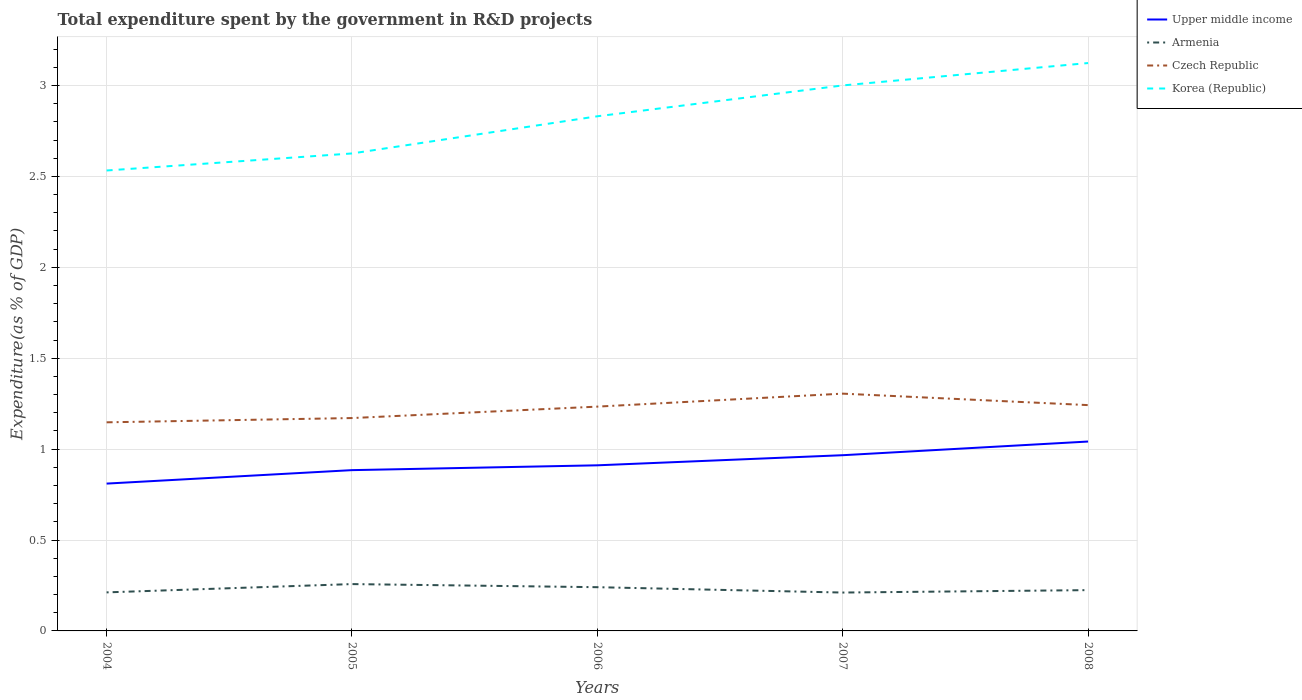How many different coloured lines are there?
Keep it short and to the point. 4. Across all years, what is the maximum total expenditure spent by the government in R&D projects in Armenia?
Your answer should be compact. 0.21. What is the total total expenditure spent by the government in R&D projects in Czech Republic in the graph?
Your response must be concise. -0.06. What is the difference between the highest and the second highest total expenditure spent by the government in R&D projects in Korea (Republic)?
Provide a short and direct response. 0.59. Is the total expenditure spent by the government in R&D projects in Armenia strictly greater than the total expenditure spent by the government in R&D projects in Czech Republic over the years?
Make the answer very short. Yes. How many lines are there?
Offer a very short reply. 4. Are the values on the major ticks of Y-axis written in scientific E-notation?
Give a very brief answer. No. Where does the legend appear in the graph?
Provide a short and direct response. Top right. How many legend labels are there?
Keep it short and to the point. 4. How are the legend labels stacked?
Give a very brief answer. Vertical. What is the title of the graph?
Provide a succinct answer. Total expenditure spent by the government in R&D projects. Does "Lesotho" appear as one of the legend labels in the graph?
Ensure brevity in your answer.  No. What is the label or title of the X-axis?
Make the answer very short. Years. What is the label or title of the Y-axis?
Make the answer very short. Expenditure(as % of GDP). What is the Expenditure(as % of GDP) of Upper middle income in 2004?
Your answer should be very brief. 0.81. What is the Expenditure(as % of GDP) in Armenia in 2004?
Your response must be concise. 0.21. What is the Expenditure(as % of GDP) of Czech Republic in 2004?
Ensure brevity in your answer.  1.15. What is the Expenditure(as % of GDP) in Korea (Republic) in 2004?
Your answer should be very brief. 2.53. What is the Expenditure(as % of GDP) of Upper middle income in 2005?
Make the answer very short. 0.88. What is the Expenditure(as % of GDP) of Armenia in 2005?
Give a very brief answer. 0.26. What is the Expenditure(as % of GDP) in Czech Republic in 2005?
Your answer should be compact. 1.17. What is the Expenditure(as % of GDP) of Korea (Republic) in 2005?
Make the answer very short. 2.63. What is the Expenditure(as % of GDP) of Upper middle income in 2006?
Provide a short and direct response. 0.91. What is the Expenditure(as % of GDP) in Armenia in 2006?
Your response must be concise. 0.24. What is the Expenditure(as % of GDP) in Czech Republic in 2006?
Offer a terse response. 1.23. What is the Expenditure(as % of GDP) of Korea (Republic) in 2006?
Offer a terse response. 2.83. What is the Expenditure(as % of GDP) of Upper middle income in 2007?
Your response must be concise. 0.97. What is the Expenditure(as % of GDP) in Armenia in 2007?
Keep it short and to the point. 0.21. What is the Expenditure(as % of GDP) in Czech Republic in 2007?
Your response must be concise. 1.31. What is the Expenditure(as % of GDP) of Korea (Republic) in 2007?
Provide a short and direct response. 3. What is the Expenditure(as % of GDP) in Upper middle income in 2008?
Offer a very short reply. 1.04. What is the Expenditure(as % of GDP) of Armenia in 2008?
Give a very brief answer. 0.22. What is the Expenditure(as % of GDP) of Czech Republic in 2008?
Provide a short and direct response. 1.24. What is the Expenditure(as % of GDP) in Korea (Republic) in 2008?
Offer a very short reply. 3.12. Across all years, what is the maximum Expenditure(as % of GDP) of Upper middle income?
Ensure brevity in your answer.  1.04. Across all years, what is the maximum Expenditure(as % of GDP) of Armenia?
Your answer should be compact. 0.26. Across all years, what is the maximum Expenditure(as % of GDP) in Czech Republic?
Provide a succinct answer. 1.31. Across all years, what is the maximum Expenditure(as % of GDP) in Korea (Republic)?
Your response must be concise. 3.12. Across all years, what is the minimum Expenditure(as % of GDP) in Upper middle income?
Offer a terse response. 0.81. Across all years, what is the minimum Expenditure(as % of GDP) in Armenia?
Your answer should be very brief. 0.21. Across all years, what is the minimum Expenditure(as % of GDP) in Czech Republic?
Your answer should be very brief. 1.15. Across all years, what is the minimum Expenditure(as % of GDP) in Korea (Republic)?
Give a very brief answer. 2.53. What is the total Expenditure(as % of GDP) of Upper middle income in the graph?
Ensure brevity in your answer.  4.61. What is the total Expenditure(as % of GDP) in Armenia in the graph?
Offer a very short reply. 1.15. What is the total Expenditure(as % of GDP) of Czech Republic in the graph?
Keep it short and to the point. 6.1. What is the total Expenditure(as % of GDP) in Korea (Republic) in the graph?
Keep it short and to the point. 14.11. What is the difference between the Expenditure(as % of GDP) in Upper middle income in 2004 and that in 2005?
Ensure brevity in your answer.  -0.07. What is the difference between the Expenditure(as % of GDP) of Armenia in 2004 and that in 2005?
Offer a terse response. -0.05. What is the difference between the Expenditure(as % of GDP) of Czech Republic in 2004 and that in 2005?
Your answer should be very brief. -0.02. What is the difference between the Expenditure(as % of GDP) of Korea (Republic) in 2004 and that in 2005?
Your response must be concise. -0.09. What is the difference between the Expenditure(as % of GDP) of Upper middle income in 2004 and that in 2006?
Offer a terse response. -0.1. What is the difference between the Expenditure(as % of GDP) of Armenia in 2004 and that in 2006?
Keep it short and to the point. -0.03. What is the difference between the Expenditure(as % of GDP) of Czech Republic in 2004 and that in 2006?
Make the answer very short. -0.09. What is the difference between the Expenditure(as % of GDP) of Korea (Republic) in 2004 and that in 2006?
Offer a very short reply. -0.3. What is the difference between the Expenditure(as % of GDP) of Upper middle income in 2004 and that in 2007?
Provide a short and direct response. -0.16. What is the difference between the Expenditure(as % of GDP) in Armenia in 2004 and that in 2007?
Ensure brevity in your answer.  0. What is the difference between the Expenditure(as % of GDP) of Czech Republic in 2004 and that in 2007?
Offer a terse response. -0.16. What is the difference between the Expenditure(as % of GDP) of Korea (Republic) in 2004 and that in 2007?
Ensure brevity in your answer.  -0.47. What is the difference between the Expenditure(as % of GDP) in Upper middle income in 2004 and that in 2008?
Make the answer very short. -0.23. What is the difference between the Expenditure(as % of GDP) in Armenia in 2004 and that in 2008?
Offer a very short reply. -0.01. What is the difference between the Expenditure(as % of GDP) in Czech Republic in 2004 and that in 2008?
Your answer should be very brief. -0.09. What is the difference between the Expenditure(as % of GDP) of Korea (Republic) in 2004 and that in 2008?
Keep it short and to the point. -0.59. What is the difference between the Expenditure(as % of GDP) in Upper middle income in 2005 and that in 2006?
Offer a very short reply. -0.03. What is the difference between the Expenditure(as % of GDP) in Armenia in 2005 and that in 2006?
Give a very brief answer. 0.02. What is the difference between the Expenditure(as % of GDP) of Czech Republic in 2005 and that in 2006?
Your response must be concise. -0.06. What is the difference between the Expenditure(as % of GDP) of Korea (Republic) in 2005 and that in 2006?
Make the answer very short. -0.2. What is the difference between the Expenditure(as % of GDP) of Upper middle income in 2005 and that in 2007?
Offer a very short reply. -0.08. What is the difference between the Expenditure(as % of GDP) of Armenia in 2005 and that in 2007?
Your answer should be very brief. 0.05. What is the difference between the Expenditure(as % of GDP) in Czech Republic in 2005 and that in 2007?
Offer a terse response. -0.13. What is the difference between the Expenditure(as % of GDP) of Korea (Republic) in 2005 and that in 2007?
Keep it short and to the point. -0.37. What is the difference between the Expenditure(as % of GDP) in Upper middle income in 2005 and that in 2008?
Make the answer very short. -0.16. What is the difference between the Expenditure(as % of GDP) of Armenia in 2005 and that in 2008?
Give a very brief answer. 0.03. What is the difference between the Expenditure(as % of GDP) in Czech Republic in 2005 and that in 2008?
Ensure brevity in your answer.  -0.07. What is the difference between the Expenditure(as % of GDP) in Korea (Republic) in 2005 and that in 2008?
Your response must be concise. -0.5. What is the difference between the Expenditure(as % of GDP) of Upper middle income in 2006 and that in 2007?
Offer a very short reply. -0.06. What is the difference between the Expenditure(as % of GDP) of Armenia in 2006 and that in 2007?
Give a very brief answer. 0.03. What is the difference between the Expenditure(as % of GDP) of Czech Republic in 2006 and that in 2007?
Your response must be concise. -0.07. What is the difference between the Expenditure(as % of GDP) of Korea (Republic) in 2006 and that in 2007?
Offer a terse response. -0.17. What is the difference between the Expenditure(as % of GDP) in Upper middle income in 2006 and that in 2008?
Ensure brevity in your answer.  -0.13. What is the difference between the Expenditure(as % of GDP) in Armenia in 2006 and that in 2008?
Ensure brevity in your answer.  0.02. What is the difference between the Expenditure(as % of GDP) in Czech Republic in 2006 and that in 2008?
Keep it short and to the point. -0.01. What is the difference between the Expenditure(as % of GDP) of Korea (Republic) in 2006 and that in 2008?
Ensure brevity in your answer.  -0.29. What is the difference between the Expenditure(as % of GDP) in Upper middle income in 2007 and that in 2008?
Offer a terse response. -0.08. What is the difference between the Expenditure(as % of GDP) in Armenia in 2007 and that in 2008?
Ensure brevity in your answer.  -0.01. What is the difference between the Expenditure(as % of GDP) of Czech Republic in 2007 and that in 2008?
Your response must be concise. 0.06. What is the difference between the Expenditure(as % of GDP) of Korea (Republic) in 2007 and that in 2008?
Make the answer very short. -0.12. What is the difference between the Expenditure(as % of GDP) in Upper middle income in 2004 and the Expenditure(as % of GDP) in Armenia in 2005?
Provide a short and direct response. 0.55. What is the difference between the Expenditure(as % of GDP) of Upper middle income in 2004 and the Expenditure(as % of GDP) of Czech Republic in 2005?
Provide a succinct answer. -0.36. What is the difference between the Expenditure(as % of GDP) in Upper middle income in 2004 and the Expenditure(as % of GDP) in Korea (Republic) in 2005?
Keep it short and to the point. -1.82. What is the difference between the Expenditure(as % of GDP) in Armenia in 2004 and the Expenditure(as % of GDP) in Czech Republic in 2005?
Ensure brevity in your answer.  -0.96. What is the difference between the Expenditure(as % of GDP) in Armenia in 2004 and the Expenditure(as % of GDP) in Korea (Republic) in 2005?
Your response must be concise. -2.41. What is the difference between the Expenditure(as % of GDP) in Czech Republic in 2004 and the Expenditure(as % of GDP) in Korea (Republic) in 2005?
Provide a short and direct response. -1.48. What is the difference between the Expenditure(as % of GDP) in Upper middle income in 2004 and the Expenditure(as % of GDP) in Armenia in 2006?
Make the answer very short. 0.57. What is the difference between the Expenditure(as % of GDP) in Upper middle income in 2004 and the Expenditure(as % of GDP) in Czech Republic in 2006?
Provide a short and direct response. -0.42. What is the difference between the Expenditure(as % of GDP) of Upper middle income in 2004 and the Expenditure(as % of GDP) of Korea (Republic) in 2006?
Keep it short and to the point. -2.02. What is the difference between the Expenditure(as % of GDP) in Armenia in 2004 and the Expenditure(as % of GDP) in Czech Republic in 2006?
Give a very brief answer. -1.02. What is the difference between the Expenditure(as % of GDP) of Armenia in 2004 and the Expenditure(as % of GDP) of Korea (Republic) in 2006?
Your response must be concise. -2.62. What is the difference between the Expenditure(as % of GDP) of Czech Republic in 2004 and the Expenditure(as % of GDP) of Korea (Republic) in 2006?
Ensure brevity in your answer.  -1.68. What is the difference between the Expenditure(as % of GDP) in Upper middle income in 2004 and the Expenditure(as % of GDP) in Armenia in 2007?
Offer a terse response. 0.6. What is the difference between the Expenditure(as % of GDP) in Upper middle income in 2004 and the Expenditure(as % of GDP) in Czech Republic in 2007?
Offer a terse response. -0.49. What is the difference between the Expenditure(as % of GDP) in Upper middle income in 2004 and the Expenditure(as % of GDP) in Korea (Republic) in 2007?
Offer a terse response. -2.19. What is the difference between the Expenditure(as % of GDP) of Armenia in 2004 and the Expenditure(as % of GDP) of Czech Republic in 2007?
Offer a terse response. -1.09. What is the difference between the Expenditure(as % of GDP) in Armenia in 2004 and the Expenditure(as % of GDP) in Korea (Republic) in 2007?
Provide a short and direct response. -2.79. What is the difference between the Expenditure(as % of GDP) of Czech Republic in 2004 and the Expenditure(as % of GDP) of Korea (Republic) in 2007?
Ensure brevity in your answer.  -1.85. What is the difference between the Expenditure(as % of GDP) in Upper middle income in 2004 and the Expenditure(as % of GDP) in Armenia in 2008?
Your answer should be very brief. 0.59. What is the difference between the Expenditure(as % of GDP) of Upper middle income in 2004 and the Expenditure(as % of GDP) of Czech Republic in 2008?
Ensure brevity in your answer.  -0.43. What is the difference between the Expenditure(as % of GDP) in Upper middle income in 2004 and the Expenditure(as % of GDP) in Korea (Republic) in 2008?
Ensure brevity in your answer.  -2.31. What is the difference between the Expenditure(as % of GDP) in Armenia in 2004 and the Expenditure(as % of GDP) in Czech Republic in 2008?
Your answer should be very brief. -1.03. What is the difference between the Expenditure(as % of GDP) in Armenia in 2004 and the Expenditure(as % of GDP) in Korea (Republic) in 2008?
Provide a short and direct response. -2.91. What is the difference between the Expenditure(as % of GDP) of Czech Republic in 2004 and the Expenditure(as % of GDP) of Korea (Republic) in 2008?
Your response must be concise. -1.98. What is the difference between the Expenditure(as % of GDP) in Upper middle income in 2005 and the Expenditure(as % of GDP) in Armenia in 2006?
Give a very brief answer. 0.64. What is the difference between the Expenditure(as % of GDP) of Upper middle income in 2005 and the Expenditure(as % of GDP) of Czech Republic in 2006?
Your answer should be compact. -0.35. What is the difference between the Expenditure(as % of GDP) of Upper middle income in 2005 and the Expenditure(as % of GDP) of Korea (Republic) in 2006?
Offer a very short reply. -1.95. What is the difference between the Expenditure(as % of GDP) of Armenia in 2005 and the Expenditure(as % of GDP) of Czech Republic in 2006?
Offer a very short reply. -0.98. What is the difference between the Expenditure(as % of GDP) of Armenia in 2005 and the Expenditure(as % of GDP) of Korea (Republic) in 2006?
Offer a very short reply. -2.57. What is the difference between the Expenditure(as % of GDP) in Czech Republic in 2005 and the Expenditure(as % of GDP) in Korea (Republic) in 2006?
Offer a terse response. -1.66. What is the difference between the Expenditure(as % of GDP) in Upper middle income in 2005 and the Expenditure(as % of GDP) in Armenia in 2007?
Your answer should be compact. 0.67. What is the difference between the Expenditure(as % of GDP) of Upper middle income in 2005 and the Expenditure(as % of GDP) of Czech Republic in 2007?
Your answer should be compact. -0.42. What is the difference between the Expenditure(as % of GDP) in Upper middle income in 2005 and the Expenditure(as % of GDP) in Korea (Republic) in 2007?
Offer a terse response. -2.12. What is the difference between the Expenditure(as % of GDP) of Armenia in 2005 and the Expenditure(as % of GDP) of Czech Republic in 2007?
Offer a terse response. -1.05. What is the difference between the Expenditure(as % of GDP) of Armenia in 2005 and the Expenditure(as % of GDP) of Korea (Republic) in 2007?
Keep it short and to the point. -2.74. What is the difference between the Expenditure(as % of GDP) of Czech Republic in 2005 and the Expenditure(as % of GDP) of Korea (Republic) in 2007?
Your response must be concise. -1.83. What is the difference between the Expenditure(as % of GDP) of Upper middle income in 2005 and the Expenditure(as % of GDP) of Armenia in 2008?
Provide a short and direct response. 0.66. What is the difference between the Expenditure(as % of GDP) in Upper middle income in 2005 and the Expenditure(as % of GDP) in Czech Republic in 2008?
Provide a short and direct response. -0.36. What is the difference between the Expenditure(as % of GDP) in Upper middle income in 2005 and the Expenditure(as % of GDP) in Korea (Republic) in 2008?
Ensure brevity in your answer.  -2.24. What is the difference between the Expenditure(as % of GDP) of Armenia in 2005 and the Expenditure(as % of GDP) of Czech Republic in 2008?
Provide a succinct answer. -0.98. What is the difference between the Expenditure(as % of GDP) in Armenia in 2005 and the Expenditure(as % of GDP) in Korea (Republic) in 2008?
Make the answer very short. -2.87. What is the difference between the Expenditure(as % of GDP) of Czech Republic in 2005 and the Expenditure(as % of GDP) of Korea (Republic) in 2008?
Your answer should be compact. -1.95. What is the difference between the Expenditure(as % of GDP) in Upper middle income in 2006 and the Expenditure(as % of GDP) in Armenia in 2007?
Your response must be concise. 0.7. What is the difference between the Expenditure(as % of GDP) in Upper middle income in 2006 and the Expenditure(as % of GDP) in Czech Republic in 2007?
Offer a very short reply. -0.39. What is the difference between the Expenditure(as % of GDP) in Upper middle income in 2006 and the Expenditure(as % of GDP) in Korea (Republic) in 2007?
Provide a short and direct response. -2.09. What is the difference between the Expenditure(as % of GDP) of Armenia in 2006 and the Expenditure(as % of GDP) of Czech Republic in 2007?
Make the answer very short. -1.06. What is the difference between the Expenditure(as % of GDP) in Armenia in 2006 and the Expenditure(as % of GDP) in Korea (Republic) in 2007?
Keep it short and to the point. -2.76. What is the difference between the Expenditure(as % of GDP) of Czech Republic in 2006 and the Expenditure(as % of GDP) of Korea (Republic) in 2007?
Provide a succinct answer. -1.77. What is the difference between the Expenditure(as % of GDP) of Upper middle income in 2006 and the Expenditure(as % of GDP) of Armenia in 2008?
Provide a short and direct response. 0.69. What is the difference between the Expenditure(as % of GDP) in Upper middle income in 2006 and the Expenditure(as % of GDP) in Czech Republic in 2008?
Offer a terse response. -0.33. What is the difference between the Expenditure(as % of GDP) in Upper middle income in 2006 and the Expenditure(as % of GDP) in Korea (Republic) in 2008?
Give a very brief answer. -2.21. What is the difference between the Expenditure(as % of GDP) of Armenia in 2006 and the Expenditure(as % of GDP) of Czech Republic in 2008?
Your response must be concise. -1. What is the difference between the Expenditure(as % of GDP) of Armenia in 2006 and the Expenditure(as % of GDP) of Korea (Republic) in 2008?
Make the answer very short. -2.88. What is the difference between the Expenditure(as % of GDP) of Czech Republic in 2006 and the Expenditure(as % of GDP) of Korea (Republic) in 2008?
Keep it short and to the point. -1.89. What is the difference between the Expenditure(as % of GDP) in Upper middle income in 2007 and the Expenditure(as % of GDP) in Armenia in 2008?
Keep it short and to the point. 0.74. What is the difference between the Expenditure(as % of GDP) in Upper middle income in 2007 and the Expenditure(as % of GDP) in Czech Republic in 2008?
Ensure brevity in your answer.  -0.28. What is the difference between the Expenditure(as % of GDP) in Upper middle income in 2007 and the Expenditure(as % of GDP) in Korea (Republic) in 2008?
Keep it short and to the point. -2.16. What is the difference between the Expenditure(as % of GDP) of Armenia in 2007 and the Expenditure(as % of GDP) of Czech Republic in 2008?
Your answer should be very brief. -1.03. What is the difference between the Expenditure(as % of GDP) in Armenia in 2007 and the Expenditure(as % of GDP) in Korea (Republic) in 2008?
Give a very brief answer. -2.91. What is the difference between the Expenditure(as % of GDP) in Czech Republic in 2007 and the Expenditure(as % of GDP) in Korea (Republic) in 2008?
Make the answer very short. -1.82. What is the average Expenditure(as % of GDP) in Upper middle income per year?
Provide a short and direct response. 0.92. What is the average Expenditure(as % of GDP) in Armenia per year?
Offer a very short reply. 0.23. What is the average Expenditure(as % of GDP) in Czech Republic per year?
Make the answer very short. 1.22. What is the average Expenditure(as % of GDP) in Korea (Republic) per year?
Your answer should be very brief. 2.82. In the year 2004, what is the difference between the Expenditure(as % of GDP) of Upper middle income and Expenditure(as % of GDP) of Armenia?
Keep it short and to the point. 0.6. In the year 2004, what is the difference between the Expenditure(as % of GDP) in Upper middle income and Expenditure(as % of GDP) in Czech Republic?
Keep it short and to the point. -0.34. In the year 2004, what is the difference between the Expenditure(as % of GDP) of Upper middle income and Expenditure(as % of GDP) of Korea (Republic)?
Your answer should be compact. -1.72. In the year 2004, what is the difference between the Expenditure(as % of GDP) of Armenia and Expenditure(as % of GDP) of Czech Republic?
Your response must be concise. -0.94. In the year 2004, what is the difference between the Expenditure(as % of GDP) in Armenia and Expenditure(as % of GDP) in Korea (Republic)?
Your answer should be compact. -2.32. In the year 2004, what is the difference between the Expenditure(as % of GDP) of Czech Republic and Expenditure(as % of GDP) of Korea (Republic)?
Keep it short and to the point. -1.39. In the year 2005, what is the difference between the Expenditure(as % of GDP) in Upper middle income and Expenditure(as % of GDP) in Armenia?
Your response must be concise. 0.63. In the year 2005, what is the difference between the Expenditure(as % of GDP) of Upper middle income and Expenditure(as % of GDP) of Czech Republic?
Offer a very short reply. -0.29. In the year 2005, what is the difference between the Expenditure(as % of GDP) in Upper middle income and Expenditure(as % of GDP) in Korea (Republic)?
Offer a very short reply. -1.74. In the year 2005, what is the difference between the Expenditure(as % of GDP) in Armenia and Expenditure(as % of GDP) in Czech Republic?
Ensure brevity in your answer.  -0.91. In the year 2005, what is the difference between the Expenditure(as % of GDP) in Armenia and Expenditure(as % of GDP) in Korea (Republic)?
Provide a short and direct response. -2.37. In the year 2005, what is the difference between the Expenditure(as % of GDP) in Czech Republic and Expenditure(as % of GDP) in Korea (Republic)?
Your answer should be very brief. -1.46. In the year 2006, what is the difference between the Expenditure(as % of GDP) of Upper middle income and Expenditure(as % of GDP) of Armenia?
Offer a terse response. 0.67. In the year 2006, what is the difference between the Expenditure(as % of GDP) in Upper middle income and Expenditure(as % of GDP) in Czech Republic?
Provide a succinct answer. -0.32. In the year 2006, what is the difference between the Expenditure(as % of GDP) in Upper middle income and Expenditure(as % of GDP) in Korea (Republic)?
Provide a short and direct response. -1.92. In the year 2006, what is the difference between the Expenditure(as % of GDP) of Armenia and Expenditure(as % of GDP) of Czech Republic?
Keep it short and to the point. -0.99. In the year 2006, what is the difference between the Expenditure(as % of GDP) in Armenia and Expenditure(as % of GDP) in Korea (Republic)?
Provide a succinct answer. -2.59. In the year 2006, what is the difference between the Expenditure(as % of GDP) in Czech Republic and Expenditure(as % of GDP) in Korea (Republic)?
Give a very brief answer. -1.6. In the year 2007, what is the difference between the Expenditure(as % of GDP) in Upper middle income and Expenditure(as % of GDP) in Armenia?
Keep it short and to the point. 0.76. In the year 2007, what is the difference between the Expenditure(as % of GDP) in Upper middle income and Expenditure(as % of GDP) in Czech Republic?
Ensure brevity in your answer.  -0.34. In the year 2007, what is the difference between the Expenditure(as % of GDP) in Upper middle income and Expenditure(as % of GDP) in Korea (Republic)?
Give a very brief answer. -2.03. In the year 2007, what is the difference between the Expenditure(as % of GDP) in Armenia and Expenditure(as % of GDP) in Czech Republic?
Keep it short and to the point. -1.09. In the year 2007, what is the difference between the Expenditure(as % of GDP) in Armenia and Expenditure(as % of GDP) in Korea (Republic)?
Your answer should be compact. -2.79. In the year 2007, what is the difference between the Expenditure(as % of GDP) in Czech Republic and Expenditure(as % of GDP) in Korea (Republic)?
Provide a short and direct response. -1.7. In the year 2008, what is the difference between the Expenditure(as % of GDP) in Upper middle income and Expenditure(as % of GDP) in Armenia?
Keep it short and to the point. 0.82. In the year 2008, what is the difference between the Expenditure(as % of GDP) of Upper middle income and Expenditure(as % of GDP) of Czech Republic?
Ensure brevity in your answer.  -0.2. In the year 2008, what is the difference between the Expenditure(as % of GDP) of Upper middle income and Expenditure(as % of GDP) of Korea (Republic)?
Give a very brief answer. -2.08. In the year 2008, what is the difference between the Expenditure(as % of GDP) in Armenia and Expenditure(as % of GDP) in Czech Republic?
Your response must be concise. -1.02. In the year 2008, what is the difference between the Expenditure(as % of GDP) of Armenia and Expenditure(as % of GDP) of Korea (Republic)?
Your answer should be compact. -2.9. In the year 2008, what is the difference between the Expenditure(as % of GDP) in Czech Republic and Expenditure(as % of GDP) in Korea (Republic)?
Your answer should be compact. -1.88. What is the ratio of the Expenditure(as % of GDP) of Upper middle income in 2004 to that in 2005?
Provide a short and direct response. 0.92. What is the ratio of the Expenditure(as % of GDP) of Armenia in 2004 to that in 2005?
Make the answer very short. 0.82. What is the ratio of the Expenditure(as % of GDP) of Upper middle income in 2004 to that in 2006?
Provide a short and direct response. 0.89. What is the ratio of the Expenditure(as % of GDP) of Armenia in 2004 to that in 2006?
Make the answer very short. 0.88. What is the ratio of the Expenditure(as % of GDP) in Czech Republic in 2004 to that in 2006?
Your response must be concise. 0.93. What is the ratio of the Expenditure(as % of GDP) in Korea (Republic) in 2004 to that in 2006?
Give a very brief answer. 0.89. What is the ratio of the Expenditure(as % of GDP) in Upper middle income in 2004 to that in 2007?
Your answer should be compact. 0.84. What is the ratio of the Expenditure(as % of GDP) in Czech Republic in 2004 to that in 2007?
Keep it short and to the point. 0.88. What is the ratio of the Expenditure(as % of GDP) of Korea (Republic) in 2004 to that in 2007?
Offer a terse response. 0.84. What is the ratio of the Expenditure(as % of GDP) in Upper middle income in 2004 to that in 2008?
Keep it short and to the point. 0.78. What is the ratio of the Expenditure(as % of GDP) of Armenia in 2004 to that in 2008?
Provide a short and direct response. 0.94. What is the ratio of the Expenditure(as % of GDP) of Czech Republic in 2004 to that in 2008?
Provide a short and direct response. 0.92. What is the ratio of the Expenditure(as % of GDP) of Korea (Republic) in 2004 to that in 2008?
Offer a very short reply. 0.81. What is the ratio of the Expenditure(as % of GDP) in Upper middle income in 2005 to that in 2006?
Keep it short and to the point. 0.97. What is the ratio of the Expenditure(as % of GDP) of Armenia in 2005 to that in 2006?
Your answer should be compact. 1.07. What is the ratio of the Expenditure(as % of GDP) of Czech Republic in 2005 to that in 2006?
Offer a terse response. 0.95. What is the ratio of the Expenditure(as % of GDP) in Korea (Republic) in 2005 to that in 2006?
Offer a very short reply. 0.93. What is the ratio of the Expenditure(as % of GDP) in Upper middle income in 2005 to that in 2007?
Give a very brief answer. 0.92. What is the ratio of the Expenditure(as % of GDP) in Armenia in 2005 to that in 2007?
Make the answer very short. 1.22. What is the ratio of the Expenditure(as % of GDP) in Czech Republic in 2005 to that in 2007?
Ensure brevity in your answer.  0.9. What is the ratio of the Expenditure(as % of GDP) of Korea (Republic) in 2005 to that in 2007?
Keep it short and to the point. 0.88. What is the ratio of the Expenditure(as % of GDP) of Upper middle income in 2005 to that in 2008?
Provide a short and direct response. 0.85. What is the ratio of the Expenditure(as % of GDP) in Armenia in 2005 to that in 2008?
Give a very brief answer. 1.15. What is the ratio of the Expenditure(as % of GDP) in Czech Republic in 2005 to that in 2008?
Your response must be concise. 0.94. What is the ratio of the Expenditure(as % of GDP) in Korea (Republic) in 2005 to that in 2008?
Keep it short and to the point. 0.84. What is the ratio of the Expenditure(as % of GDP) of Upper middle income in 2006 to that in 2007?
Keep it short and to the point. 0.94. What is the ratio of the Expenditure(as % of GDP) in Armenia in 2006 to that in 2007?
Offer a terse response. 1.14. What is the ratio of the Expenditure(as % of GDP) in Czech Republic in 2006 to that in 2007?
Your answer should be compact. 0.95. What is the ratio of the Expenditure(as % of GDP) in Korea (Republic) in 2006 to that in 2007?
Offer a terse response. 0.94. What is the ratio of the Expenditure(as % of GDP) in Upper middle income in 2006 to that in 2008?
Offer a very short reply. 0.87. What is the ratio of the Expenditure(as % of GDP) of Armenia in 2006 to that in 2008?
Offer a very short reply. 1.07. What is the ratio of the Expenditure(as % of GDP) in Korea (Republic) in 2006 to that in 2008?
Make the answer very short. 0.91. What is the ratio of the Expenditure(as % of GDP) in Upper middle income in 2007 to that in 2008?
Provide a short and direct response. 0.93. What is the ratio of the Expenditure(as % of GDP) in Armenia in 2007 to that in 2008?
Offer a very short reply. 0.94. What is the ratio of the Expenditure(as % of GDP) in Czech Republic in 2007 to that in 2008?
Ensure brevity in your answer.  1.05. What is the ratio of the Expenditure(as % of GDP) of Korea (Republic) in 2007 to that in 2008?
Provide a short and direct response. 0.96. What is the difference between the highest and the second highest Expenditure(as % of GDP) of Upper middle income?
Provide a short and direct response. 0.08. What is the difference between the highest and the second highest Expenditure(as % of GDP) of Armenia?
Offer a very short reply. 0.02. What is the difference between the highest and the second highest Expenditure(as % of GDP) in Czech Republic?
Give a very brief answer. 0.06. What is the difference between the highest and the second highest Expenditure(as % of GDP) in Korea (Republic)?
Offer a very short reply. 0.12. What is the difference between the highest and the lowest Expenditure(as % of GDP) in Upper middle income?
Keep it short and to the point. 0.23. What is the difference between the highest and the lowest Expenditure(as % of GDP) in Armenia?
Provide a short and direct response. 0.05. What is the difference between the highest and the lowest Expenditure(as % of GDP) of Czech Republic?
Provide a short and direct response. 0.16. What is the difference between the highest and the lowest Expenditure(as % of GDP) of Korea (Republic)?
Your response must be concise. 0.59. 